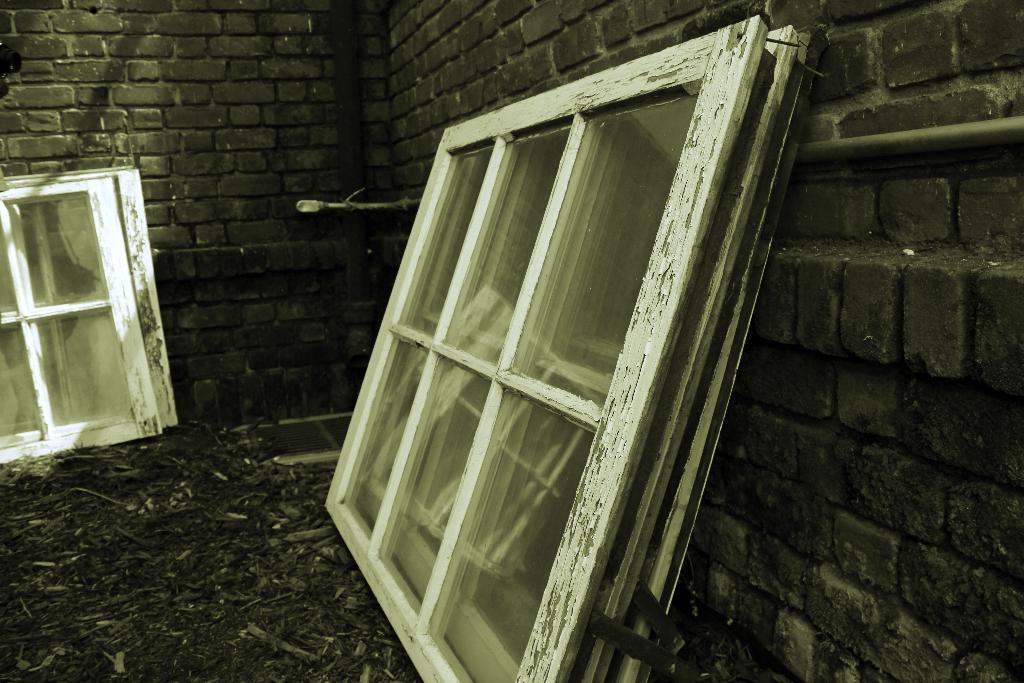Can you describe this image briefly? This image consists of a wall made up of bricks. And there are windows in white color. At the bottom, there is a ground. 